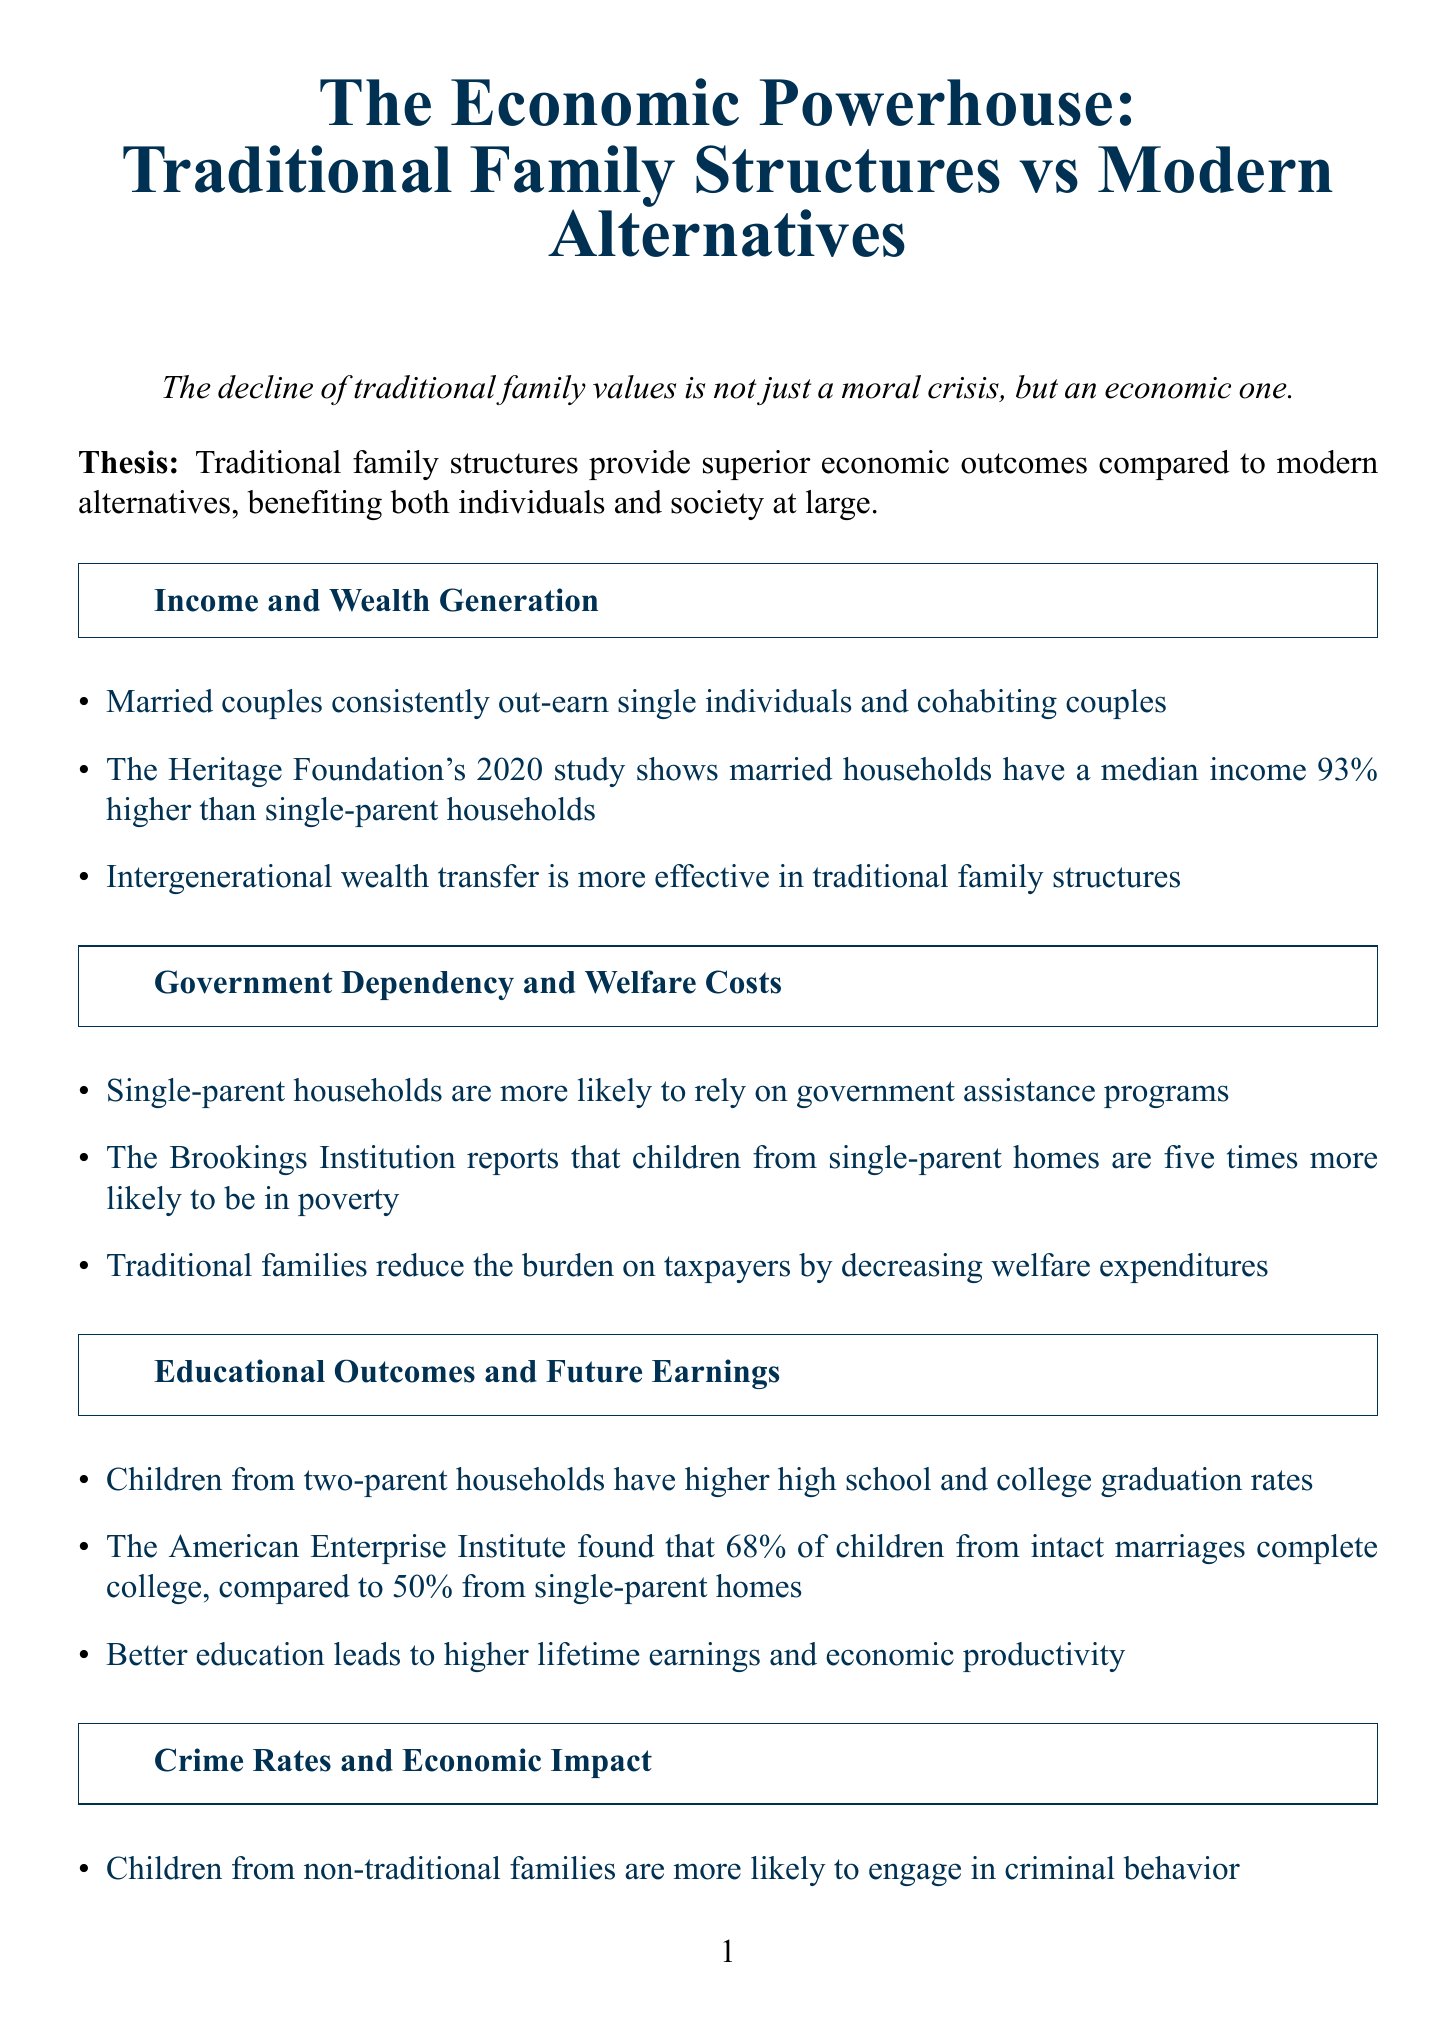What is the thesis of the report? The thesis states the comparison of economic outcomes between traditional family structures and modern alternatives, emphasizing the advantages of the former.
Answer: Traditional family structures provide superior economic outcomes compared to modern alternatives What is the median income difference between married households and single-parent households according to the Heritage Foundation's study? It highlights the economic disparity in median income, showcasing how much more married households earn than single-parent households.
Answer: 93% higher What percentage of children from intact marriages complete college? This statistic illustrates how traditional family structures influence educational attainment among children.
Answer: 68% What correlation does Detroit's economic downturn have with family structures? It emphasizes the relationship between economic decline and the deterioration of traditional family units in this city.
Answer: Breakdown of traditional family structures According to the National Fatherhood Initiative, what percentage of youth in prison come from fatherless homes? This statistic highlights the impact of family structure on criminal behavior among youth, as mentioned in the document.
Answer: 85% What are the two case studies mentioned in the report? These case studies provide real-world examples illustrating the economic implications of different family structures.
Answer: Utah's Economic Success and The Detroit Decline Who stated that marriage is America's strongest anti-poverty weapon? This quote underscores the importance placed on marriage in combating poverty and its economic implications.
Answer: Robert Rector What does the report call for at the end? This is a direct appeal made to policymakers and citizens regarding the support for traditional family structures in relation to the economy.
Answer: Support the traditional family as the cornerstone of a prosperous economy 